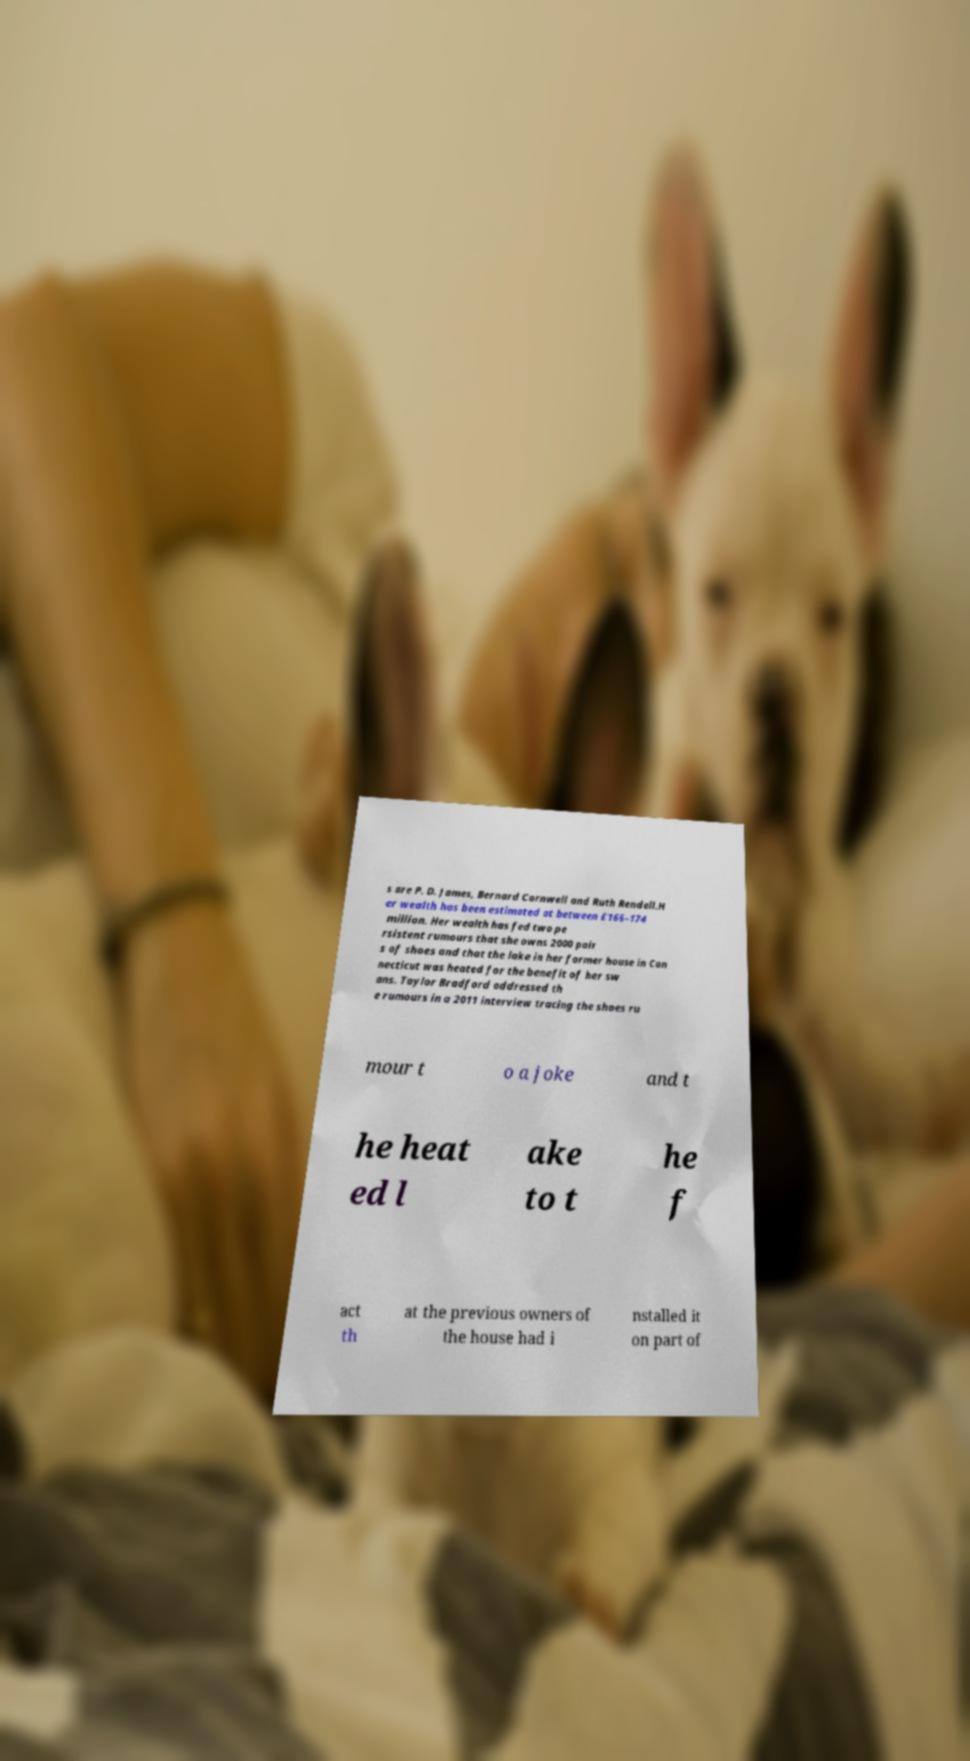I need the written content from this picture converted into text. Can you do that? s are P. D. James, Bernard Cornwell and Ruth Rendell.H er wealth has been estimated at between £166–174 million. Her wealth has fed two pe rsistent rumours that she owns 2000 pair s of shoes and that the lake in her former house in Con necticut was heated for the benefit of her sw ans. Taylor Bradford addressed th e rumours in a 2011 interview tracing the shoes ru mour t o a joke and t he heat ed l ake to t he f act th at the previous owners of the house had i nstalled it on part of 